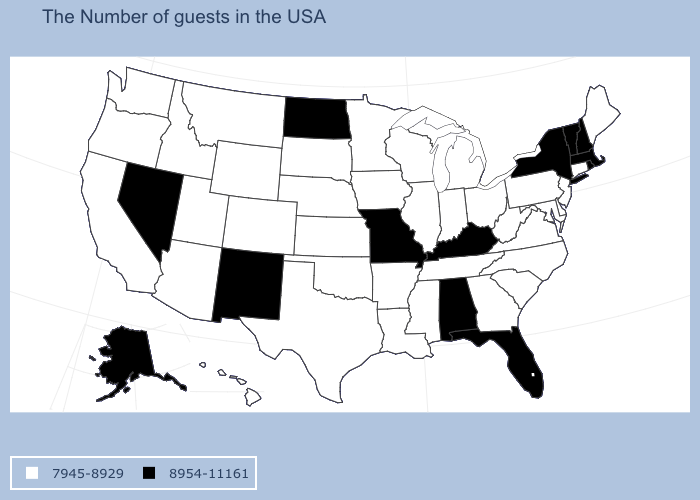What is the value of Arkansas?
Write a very short answer. 7945-8929. What is the value of Florida?
Give a very brief answer. 8954-11161. Among the states that border Connecticut , which have the highest value?
Answer briefly. Massachusetts, Rhode Island, New York. What is the value of California?
Quick response, please. 7945-8929. Name the states that have a value in the range 8954-11161?
Be succinct. Massachusetts, Rhode Island, New Hampshire, Vermont, New York, Florida, Kentucky, Alabama, Missouri, North Dakota, New Mexico, Nevada, Alaska. Does New York have the highest value in the USA?
Concise answer only. Yes. Name the states that have a value in the range 8954-11161?
Give a very brief answer. Massachusetts, Rhode Island, New Hampshire, Vermont, New York, Florida, Kentucky, Alabama, Missouri, North Dakota, New Mexico, Nevada, Alaska. What is the highest value in states that border Kansas?
Be succinct. 8954-11161. Among the states that border Texas , which have the lowest value?
Answer briefly. Louisiana, Arkansas, Oklahoma. Which states hav the highest value in the MidWest?
Concise answer only. Missouri, North Dakota. What is the value of North Carolina?
Answer briefly. 7945-8929. Name the states that have a value in the range 7945-8929?
Short answer required. Maine, Connecticut, New Jersey, Delaware, Maryland, Pennsylvania, Virginia, North Carolina, South Carolina, West Virginia, Ohio, Georgia, Michigan, Indiana, Tennessee, Wisconsin, Illinois, Mississippi, Louisiana, Arkansas, Minnesota, Iowa, Kansas, Nebraska, Oklahoma, Texas, South Dakota, Wyoming, Colorado, Utah, Montana, Arizona, Idaho, California, Washington, Oregon, Hawaii. What is the value of South Carolina?
Answer briefly. 7945-8929. Among the states that border Alabama , which have the highest value?
Be succinct. Florida. Name the states that have a value in the range 8954-11161?
Write a very short answer. Massachusetts, Rhode Island, New Hampshire, Vermont, New York, Florida, Kentucky, Alabama, Missouri, North Dakota, New Mexico, Nevada, Alaska. 